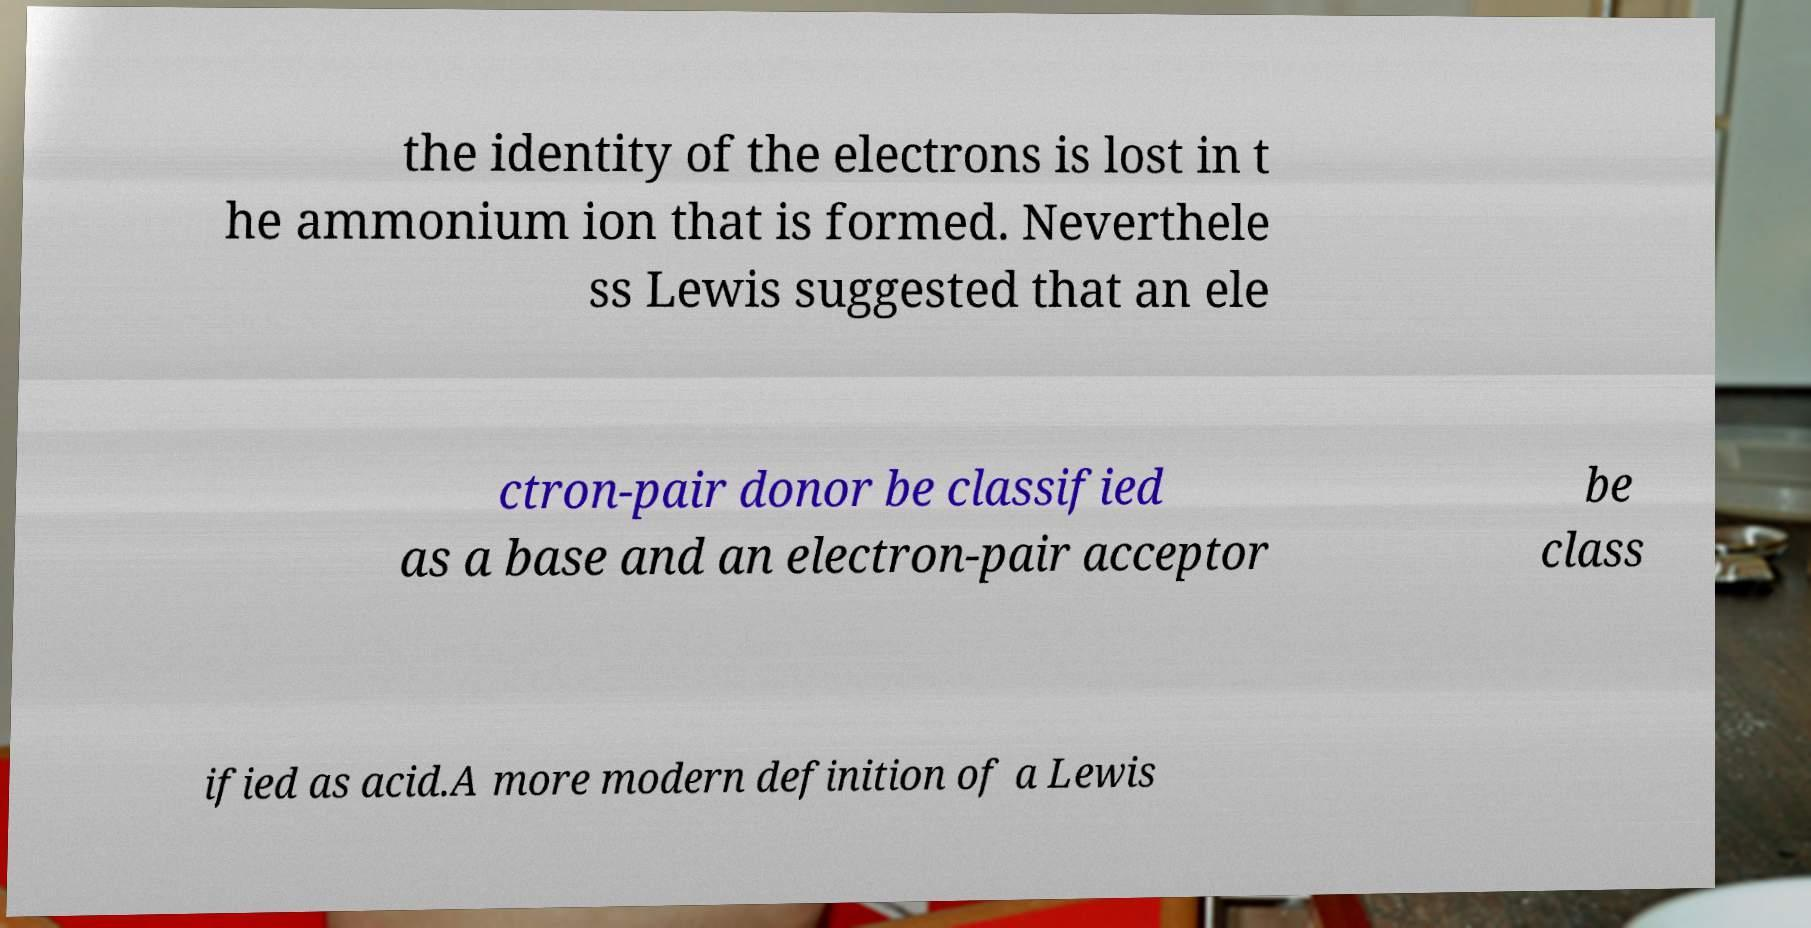Could you assist in decoding the text presented in this image and type it out clearly? the identity of the electrons is lost in t he ammonium ion that is formed. Neverthele ss Lewis suggested that an ele ctron-pair donor be classified as a base and an electron-pair acceptor be class ified as acid.A more modern definition of a Lewis 